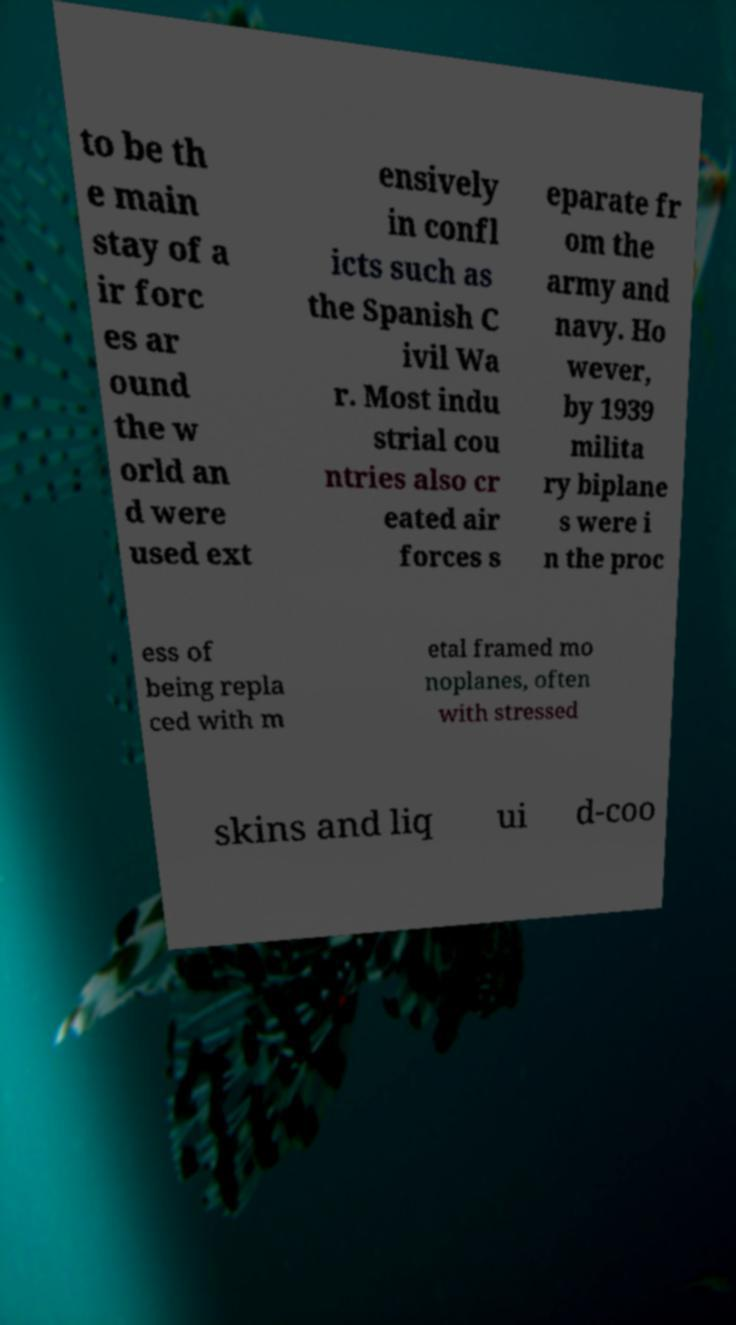For documentation purposes, I need the text within this image transcribed. Could you provide that? to be th e main stay of a ir forc es ar ound the w orld an d were used ext ensively in confl icts such as the Spanish C ivil Wa r. Most indu strial cou ntries also cr eated air forces s eparate fr om the army and navy. Ho wever, by 1939 milita ry biplane s were i n the proc ess of being repla ced with m etal framed mo noplanes, often with stressed skins and liq ui d-coo 